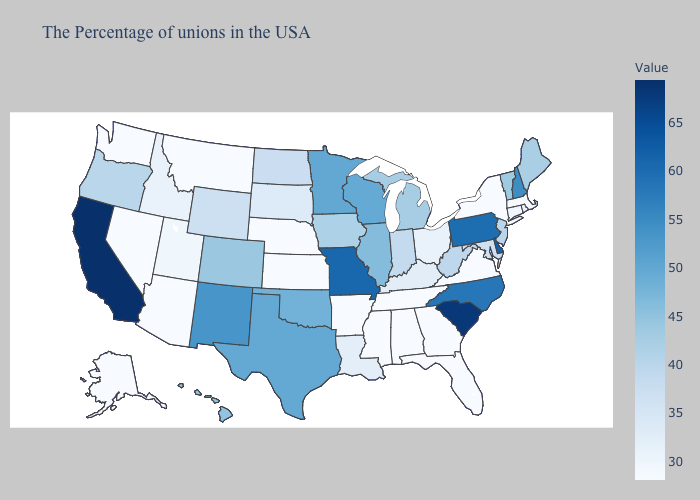Does Tennessee have a lower value than Wisconsin?
Write a very short answer. Yes. Does the map have missing data?
Be succinct. No. Does Delaware have the lowest value in the South?
Quick response, please. No. 